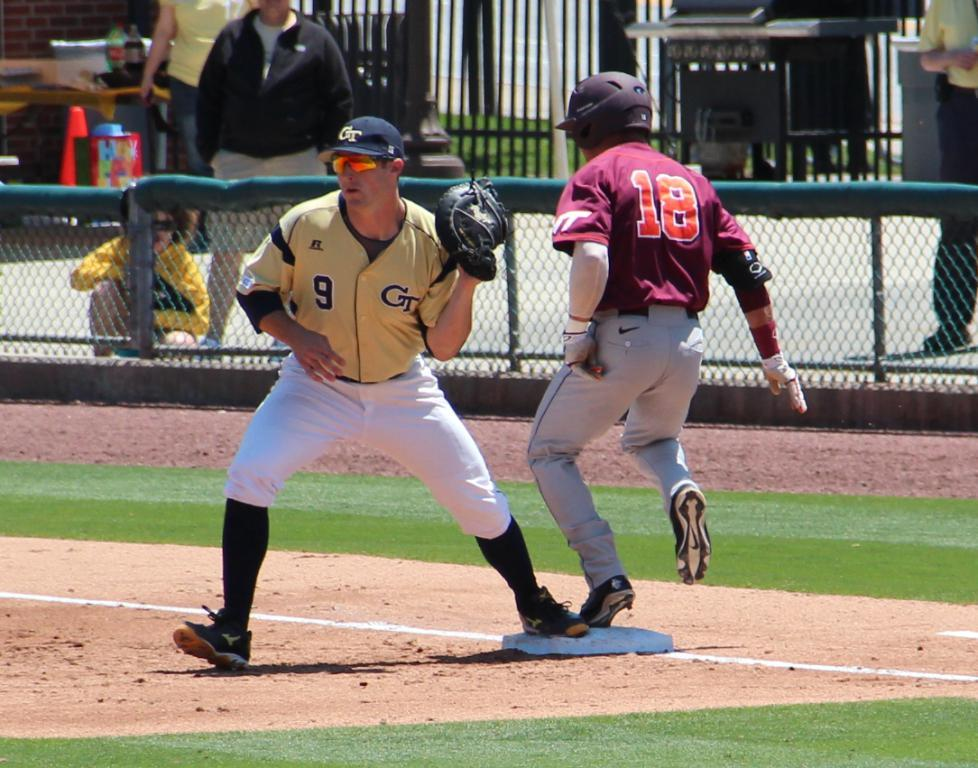<image>
Write a terse but informative summary of the picture. Player number 18 in the maroon shirt has his left foot on the base. 